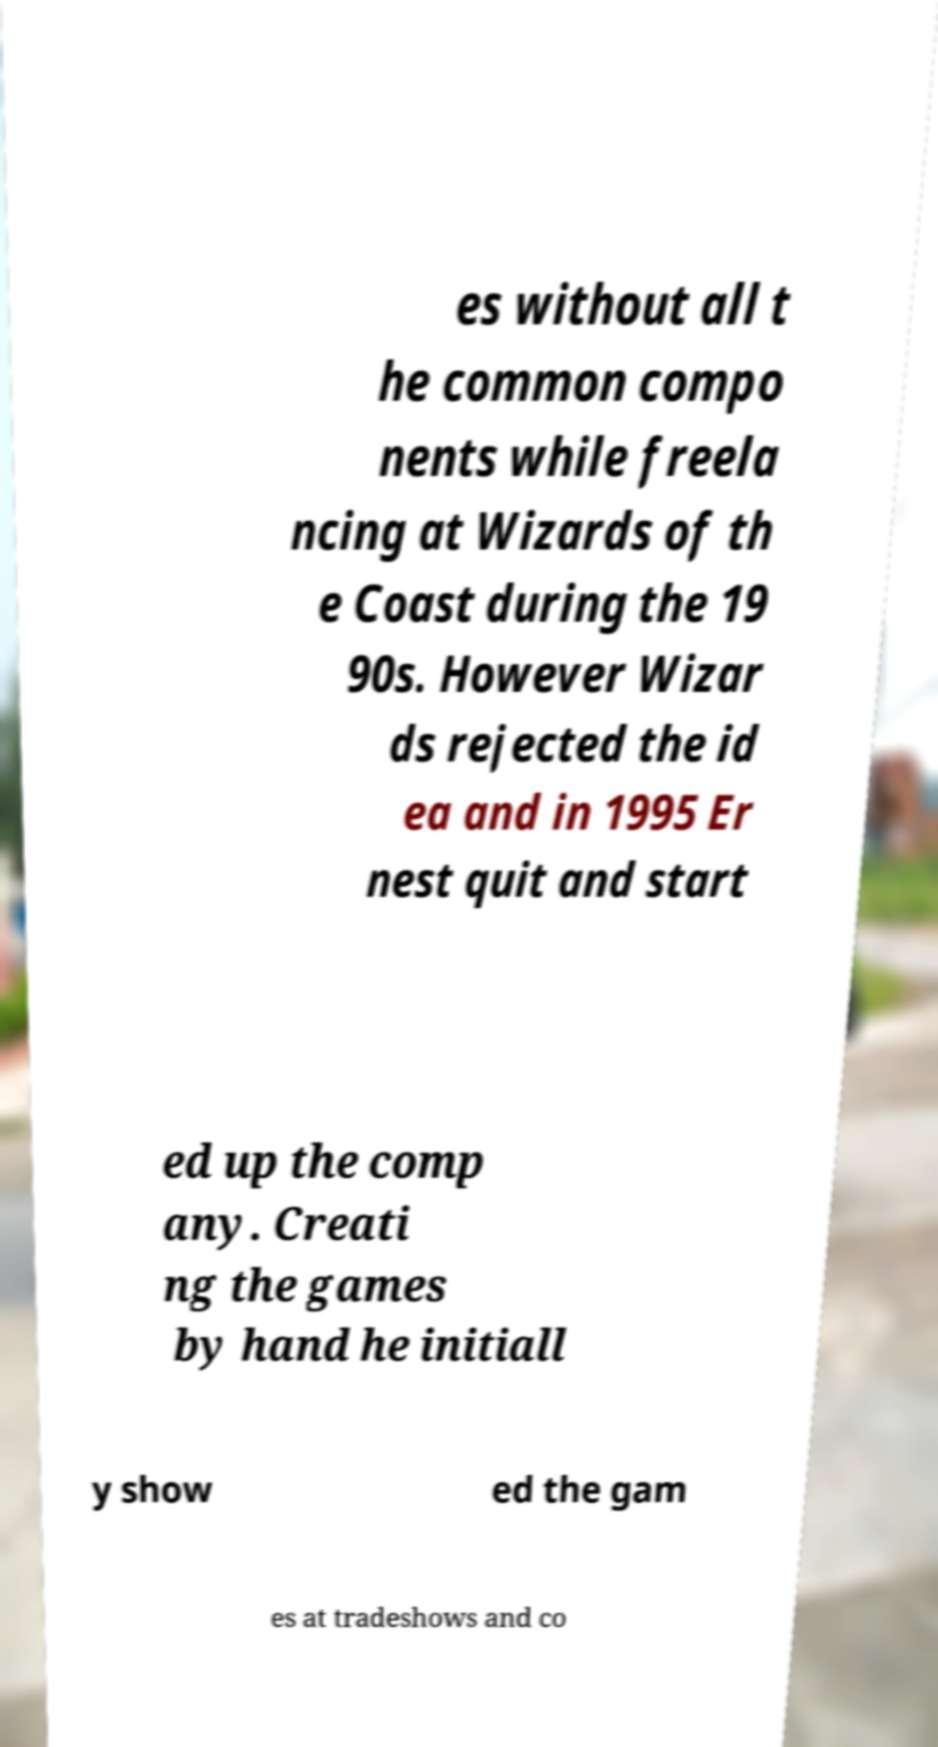Can you accurately transcribe the text from the provided image for me? es without all t he common compo nents while freela ncing at Wizards of th e Coast during the 19 90s. However Wizar ds rejected the id ea and in 1995 Er nest quit and start ed up the comp any. Creati ng the games by hand he initiall y show ed the gam es at tradeshows and co 